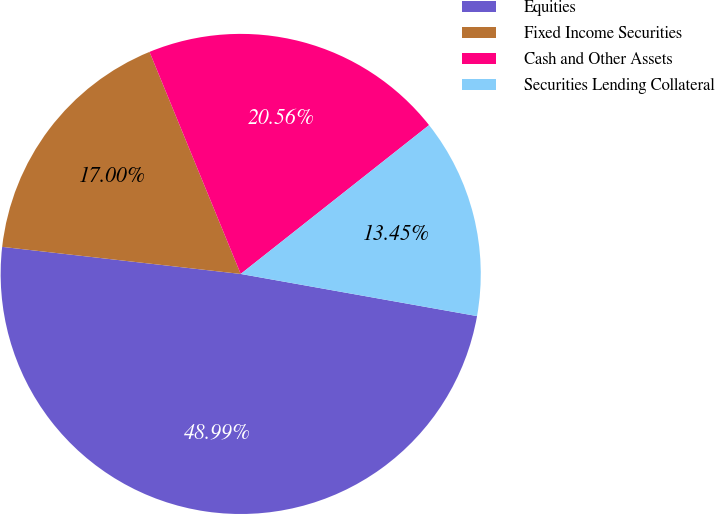<chart> <loc_0><loc_0><loc_500><loc_500><pie_chart><fcel>Equities<fcel>Fixed Income Securities<fcel>Cash and Other Assets<fcel>Securities Lending Collateral<nl><fcel>48.99%<fcel>17.0%<fcel>20.56%<fcel>13.45%<nl></chart> 